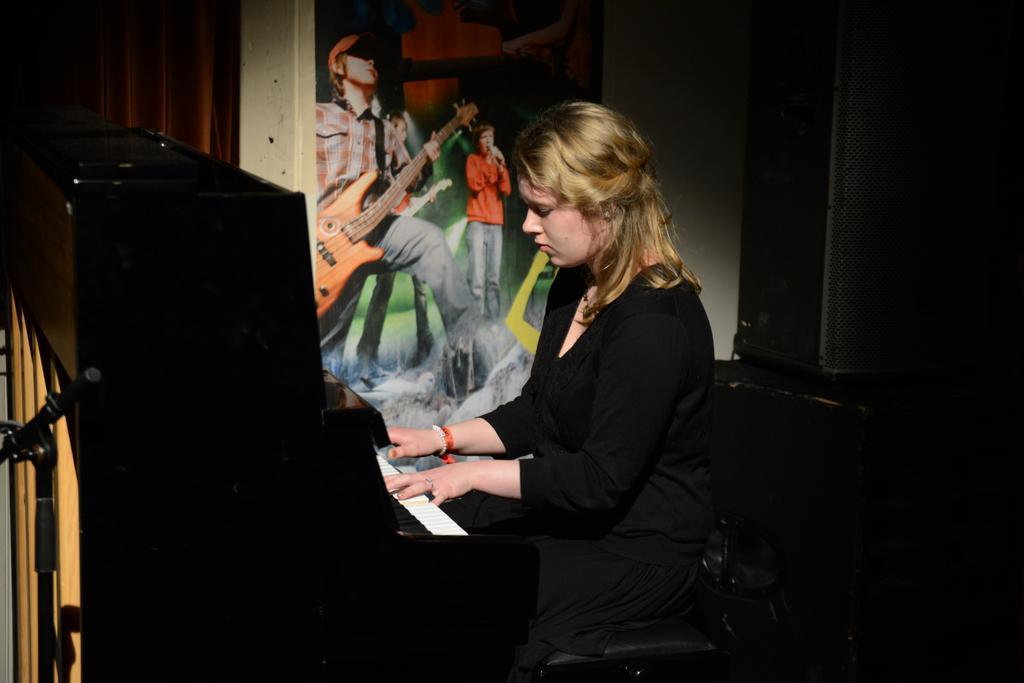Could you give a brief overview of what you see in this image? In the center of the image, we can see a lady sitting and playing piano. In the background, there is a poster placed on the wall and we can see a sound box. 